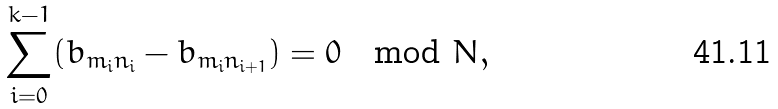Convert formula to latex. <formula><loc_0><loc_0><loc_500><loc_500>\sum _ { i = 0 } ^ { k - 1 } ( b _ { m _ { i } n _ { i } } - b _ { m _ { i } n _ { i + 1 } } ) = 0 \mod N ,</formula> 